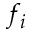Convert formula to latex. <formula><loc_0><loc_0><loc_500><loc_500>f _ { i }</formula> 